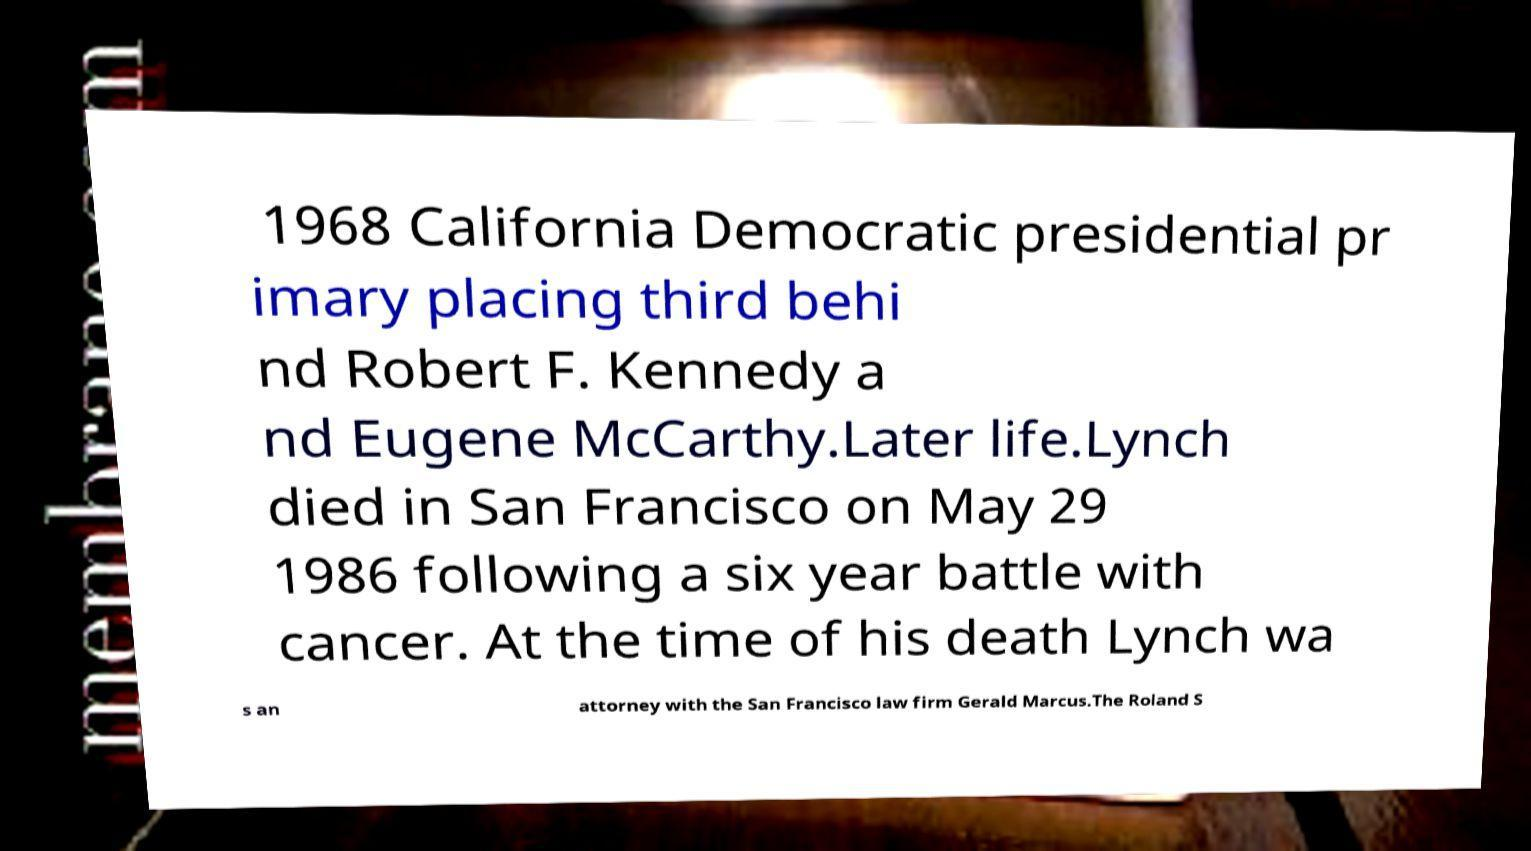What messages or text are displayed in this image? I need them in a readable, typed format. 1968 California Democratic presidential pr imary placing third behi nd Robert F. Kennedy a nd Eugene McCarthy.Later life.Lynch died in San Francisco on May 29 1986 following a six year battle with cancer. At the time of his death Lynch wa s an attorney with the San Francisco law firm Gerald Marcus.The Roland S 